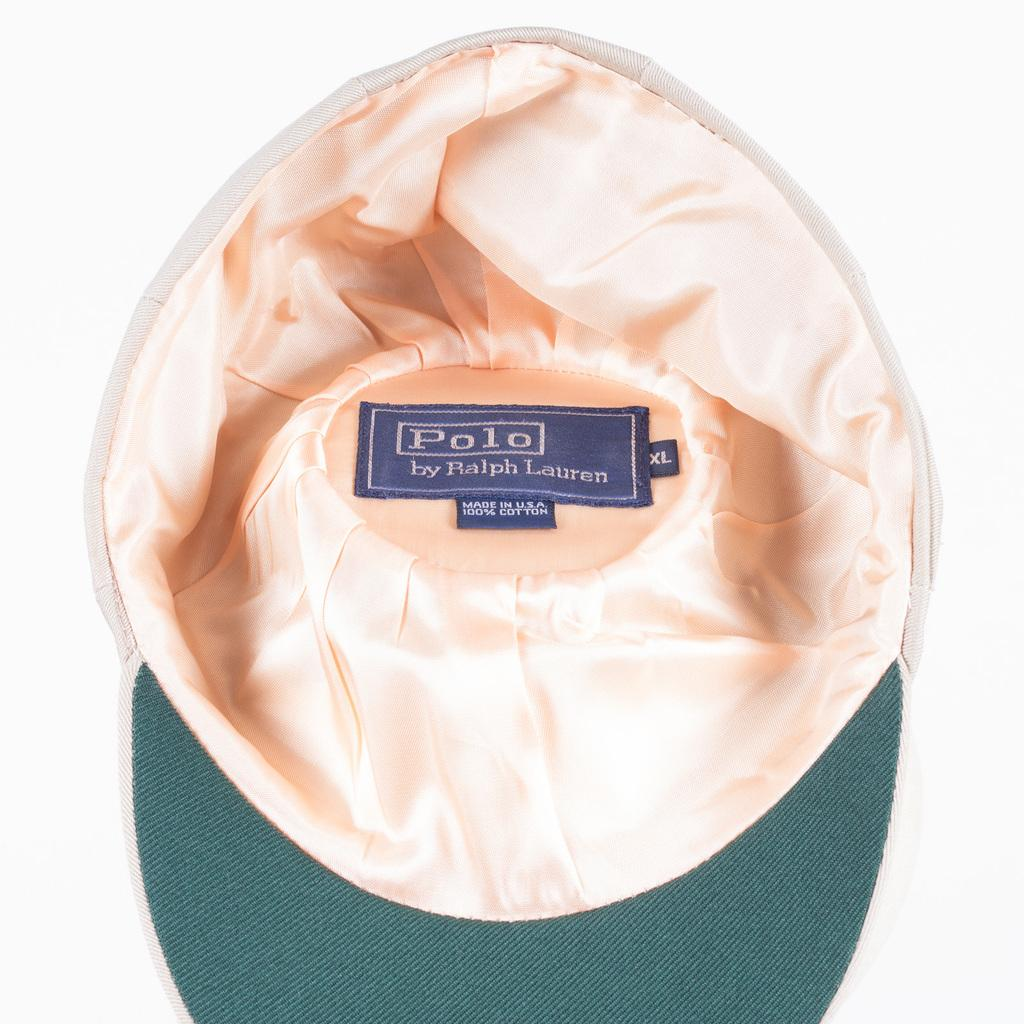What object is present in the image? There is a cap in the image. What else can be seen in the image besides the cap? There is some text in the image. What is visible in the background of the image? The background of the image features a plane. What type of flag is being waved by the vessel in the image? There is no flag or vessel present in the image; it only features a cap and text against a background with a plane. 